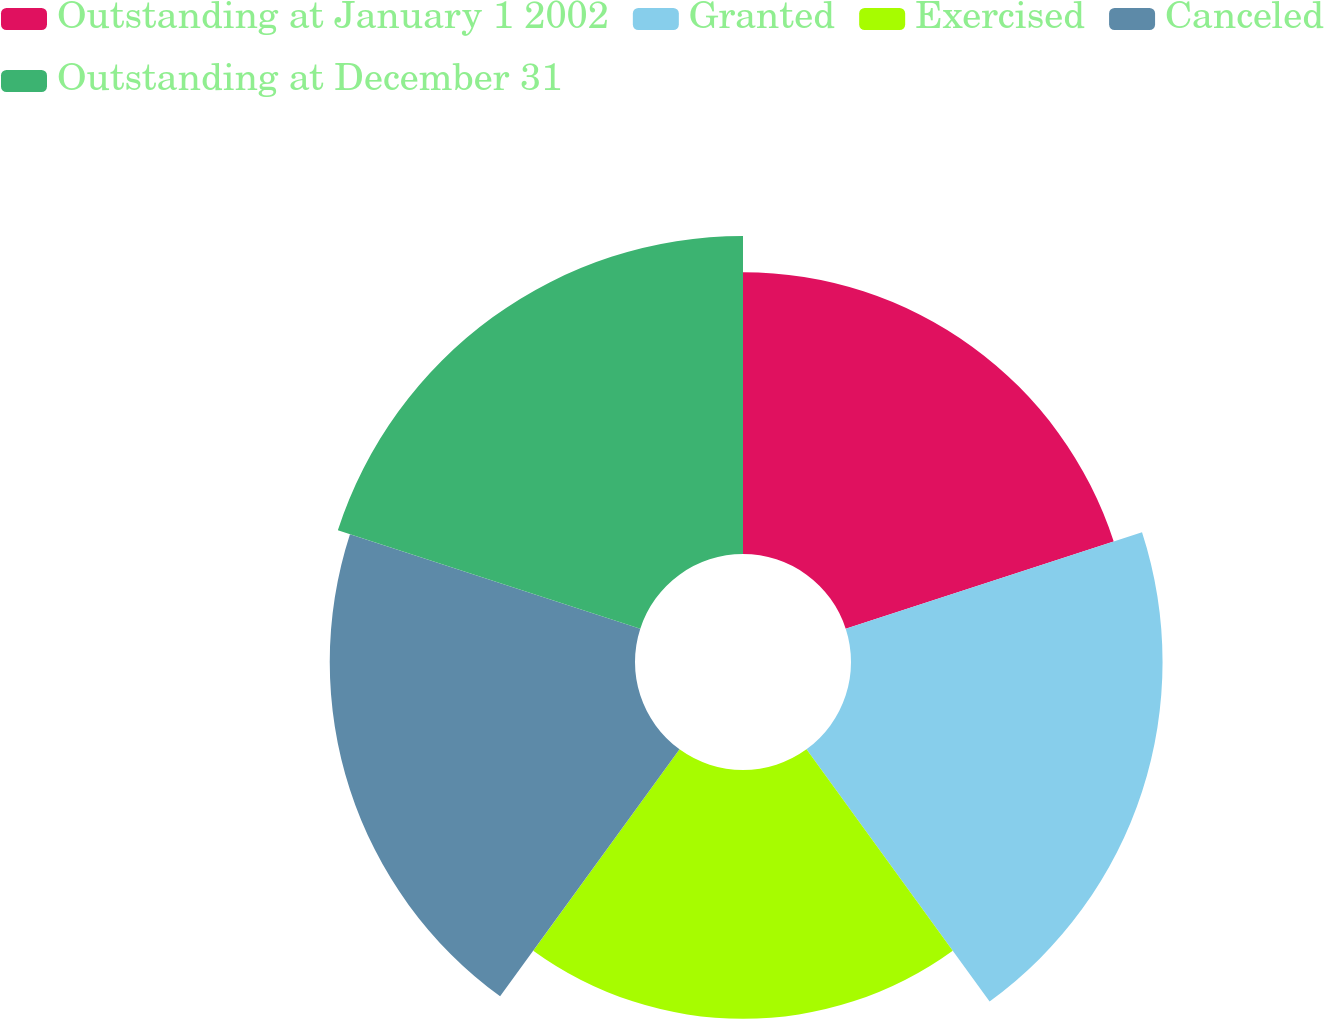Convert chart. <chart><loc_0><loc_0><loc_500><loc_500><pie_chart><fcel>Outstanding at January 1 2002<fcel>Granted<fcel>Exercised<fcel>Canceled<fcel>Outstanding at December 31<nl><fcel>19.23%<fcel>21.26%<fcel>16.98%<fcel>20.83%<fcel>21.7%<nl></chart> 